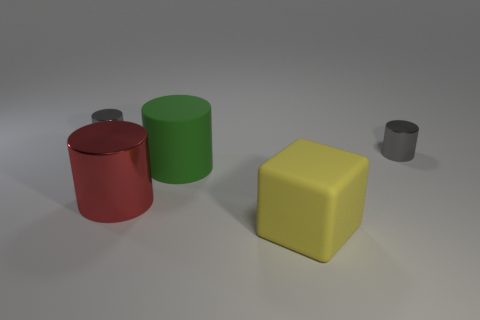Are there fewer small gray shiny things than red blocks?
Give a very brief answer. No. Is the green rubber object the same shape as the red metallic object?
Ensure brevity in your answer.  Yes. What number of things are big green cylinders or tiny things to the right of the large red cylinder?
Your answer should be compact. 2. What number of small purple metallic cylinders are there?
Ensure brevity in your answer.  0. Is there a green metal block that has the same size as the green thing?
Keep it short and to the point. No. Is the number of matte things that are behind the green rubber cylinder less than the number of large yellow things?
Ensure brevity in your answer.  Yes. Is the size of the matte cylinder the same as the block?
Make the answer very short. Yes. What is the size of the green cylinder that is the same material as the yellow thing?
Offer a very short reply. Large. What number of small shiny objects are the same color as the large metallic cylinder?
Your response must be concise. 0. Is the number of tiny gray objects behind the big red metallic cylinder less than the number of tiny gray cylinders to the left of the large yellow matte thing?
Provide a short and direct response. No. 